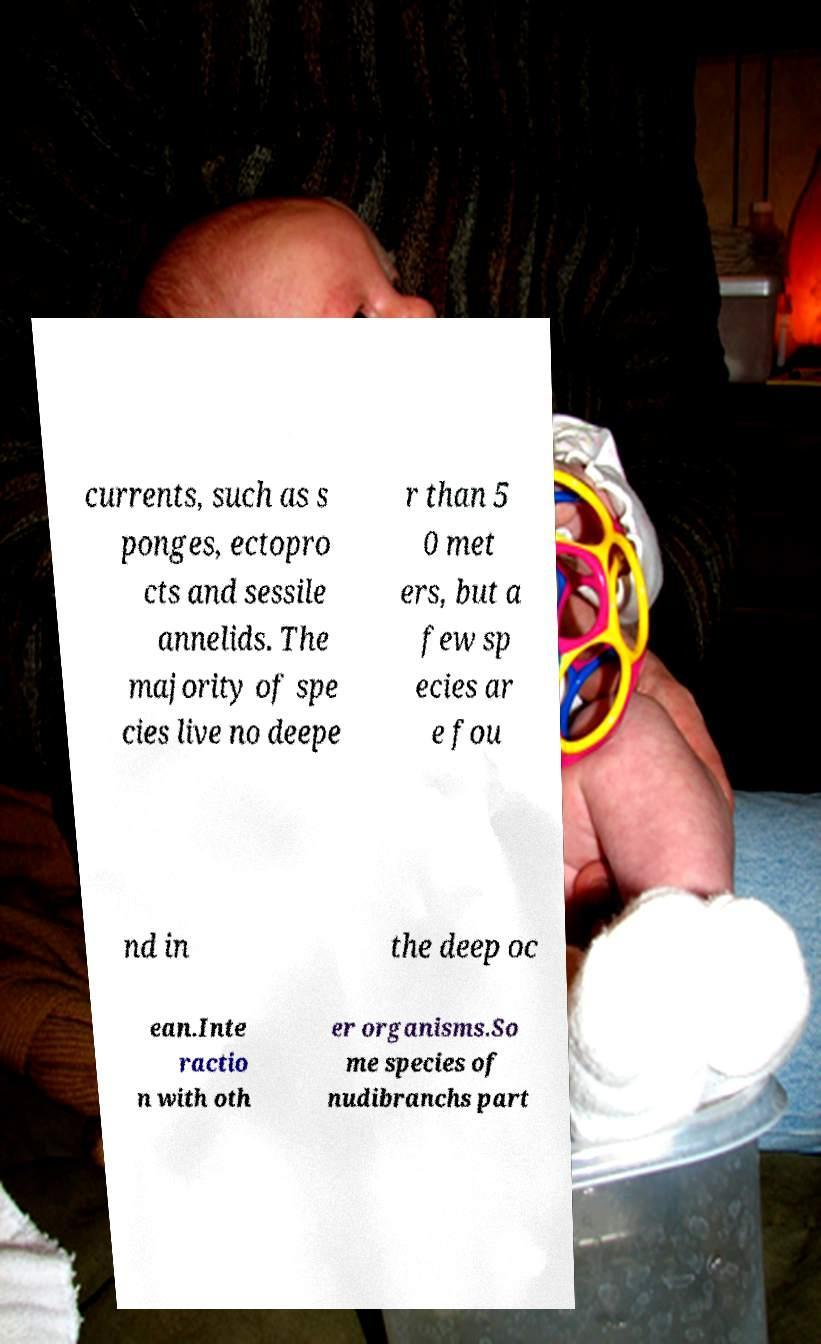Please identify and transcribe the text found in this image. currents, such as s ponges, ectopro cts and sessile annelids. The majority of spe cies live no deepe r than 5 0 met ers, but a few sp ecies ar e fou nd in the deep oc ean.Inte ractio n with oth er organisms.So me species of nudibranchs part 